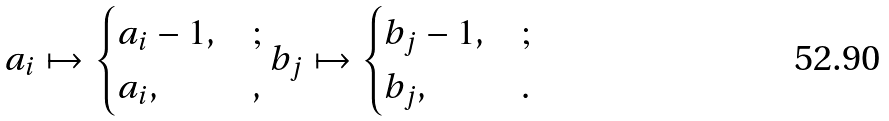<formula> <loc_0><loc_0><loc_500><loc_500>a _ { i } \mapsto \begin{cases} a _ { i } - 1 , & ; \\ a _ { i } , & , \end{cases} b _ { j } \mapsto \begin{cases} b _ { j } - 1 , & ; \\ b _ { j } , & . \end{cases}</formula> 